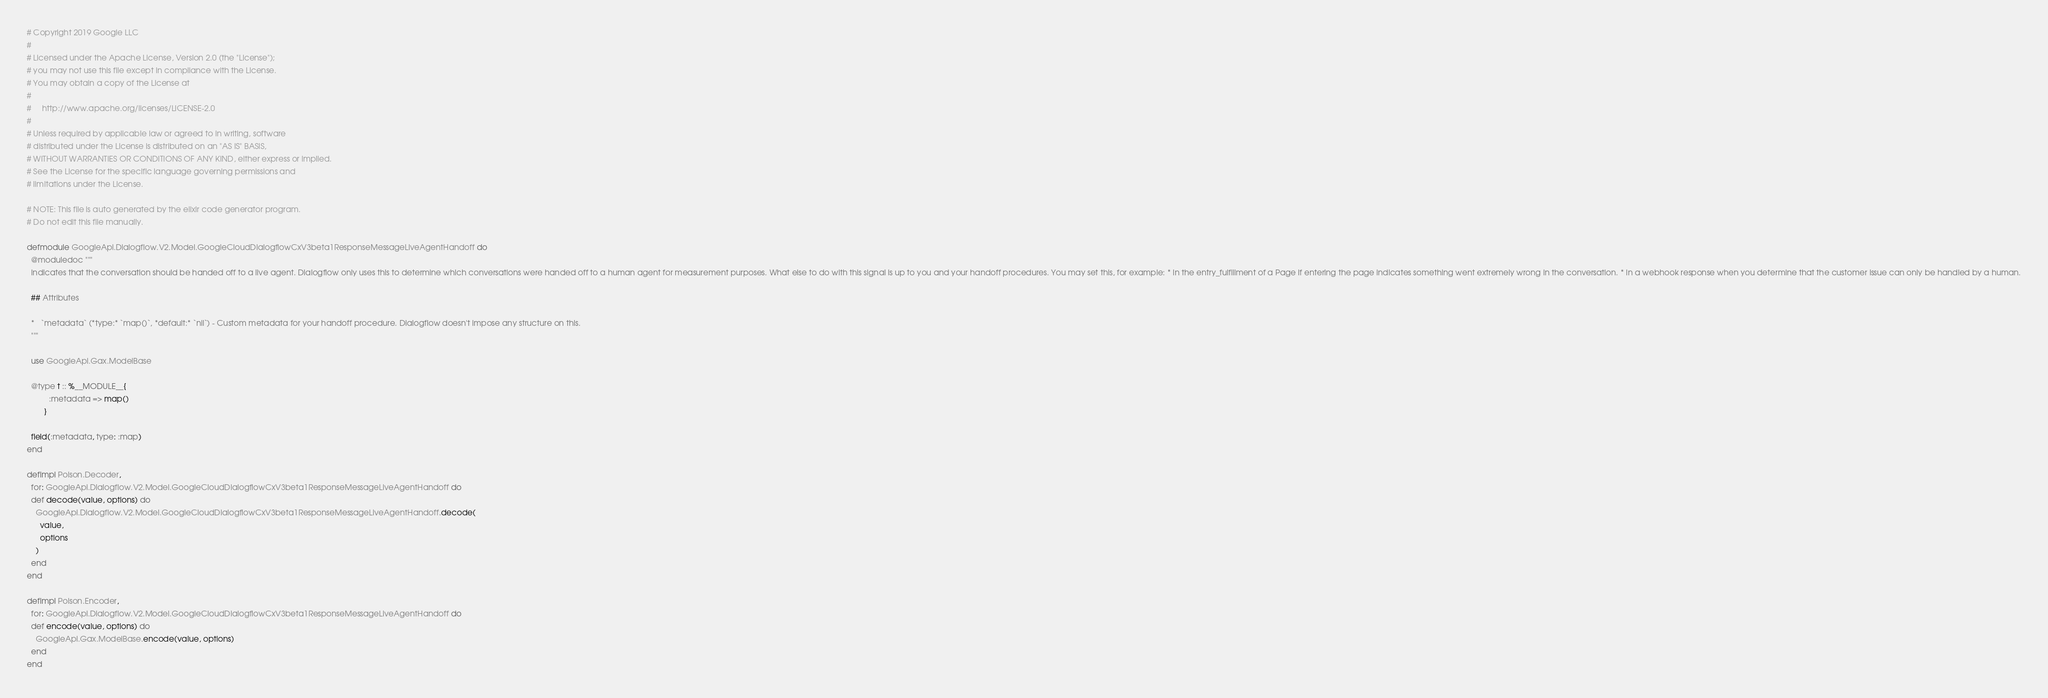<code> <loc_0><loc_0><loc_500><loc_500><_Elixir_># Copyright 2019 Google LLC
#
# Licensed under the Apache License, Version 2.0 (the "License");
# you may not use this file except in compliance with the License.
# You may obtain a copy of the License at
#
#     http://www.apache.org/licenses/LICENSE-2.0
#
# Unless required by applicable law or agreed to in writing, software
# distributed under the License is distributed on an "AS IS" BASIS,
# WITHOUT WARRANTIES OR CONDITIONS OF ANY KIND, either express or implied.
# See the License for the specific language governing permissions and
# limitations under the License.

# NOTE: This file is auto generated by the elixir code generator program.
# Do not edit this file manually.

defmodule GoogleApi.Dialogflow.V2.Model.GoogleCloudDialogflowCxV3beta1ResponseMessageLiveAgentHandoff do
  @moduledoc """
  Indicates that the conversation should be handed off to a live agent. Dialogflow only uses this to determine which conversations were handed off to a human agent for measurement purposes. What else to do with this signal is up to you and your handoff procedures. You may set this, for example: * In the entry_fulfillment of a Page if entering the page indicates something went extremely wrong in the conversation. * In a webhook response when you determine that the customer issue can only be handled by a human.

  ## Attributes

  *   `metadata` (*type:* `map()`, *default:* `nil`) - Custom metadata for your handoff procedure. Dialogflow doesn't impose any structure on this.
  """

  use GoogleApi.Gax.ModelBase

  @type t :: %__MODULE__{
          :metadata => map()
        }

  field(:metadata, type: :map)
end

defimpl Poison.Decoder,
  for: GoogleApi.Dialogflow.V2.Model.GoogleCloudDialogflowCxV3beta1ResponseMessageLiveAgentHandoff do
  def decode(value, options) do
    GoogleApi.Dialogflow.V2.Model.GoogleCloudDialogflowCxV3beta1ResponseMessageLiveAgentHandoff.decode(
      value,
      options
    )
  end
end

defimpl Poison.Encoder,
  for: GoogleApi.Dialogflow.V2.Model.GoogleCloudDialogflowCxV3beta1ResponseMessageLiveAgentHandoff do
  def encode(value, options) do
    GoogleApi.Gax.ModelBase.encode(value, options)
  end
end
</code> 